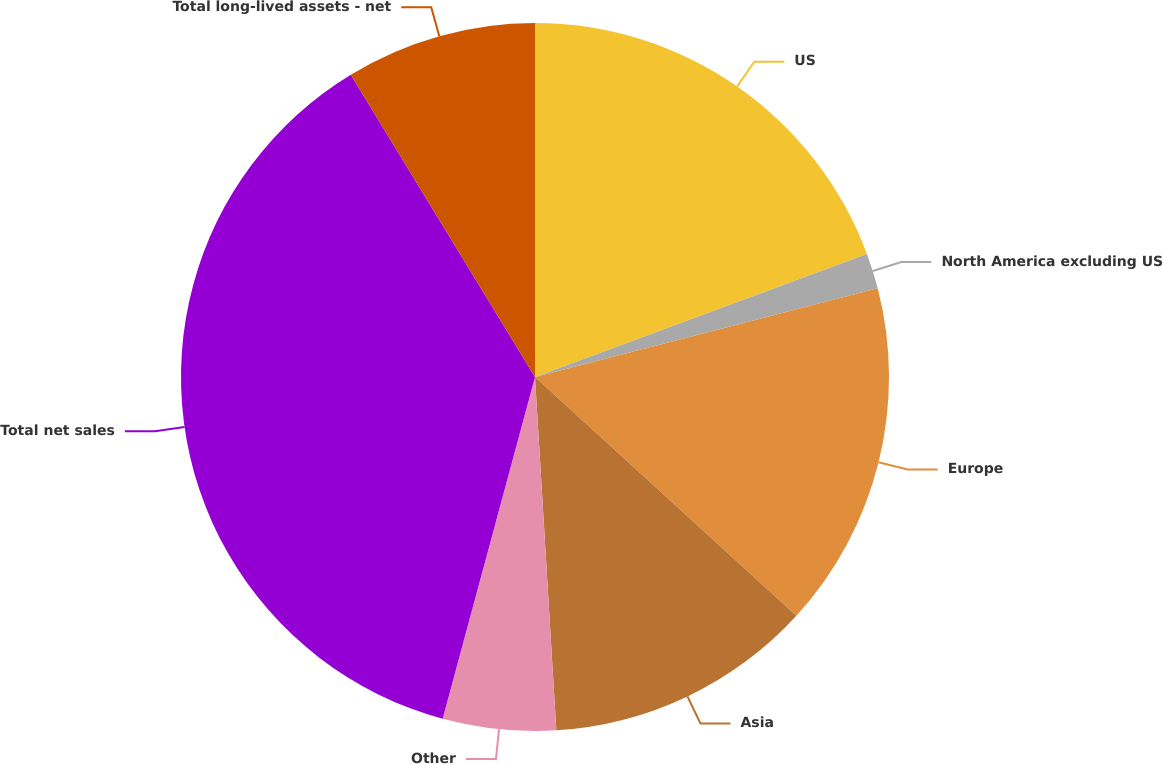<chart> <loc_0><loc_0><loc_500><loc_500><pie_chart><fcel>US<fcel>North America excluding US<fcel>Europe<fcel>Asia<fcel>Other<fcel>Total net sales<fcel>Total long-lived assets - net<nl><fcel>19.35%<fcel>1.62%<fcel>15.81%<fcel>12.26%<fcel>5.16%<fcel>37.09%<fcel>8.71%<nl></chart> 